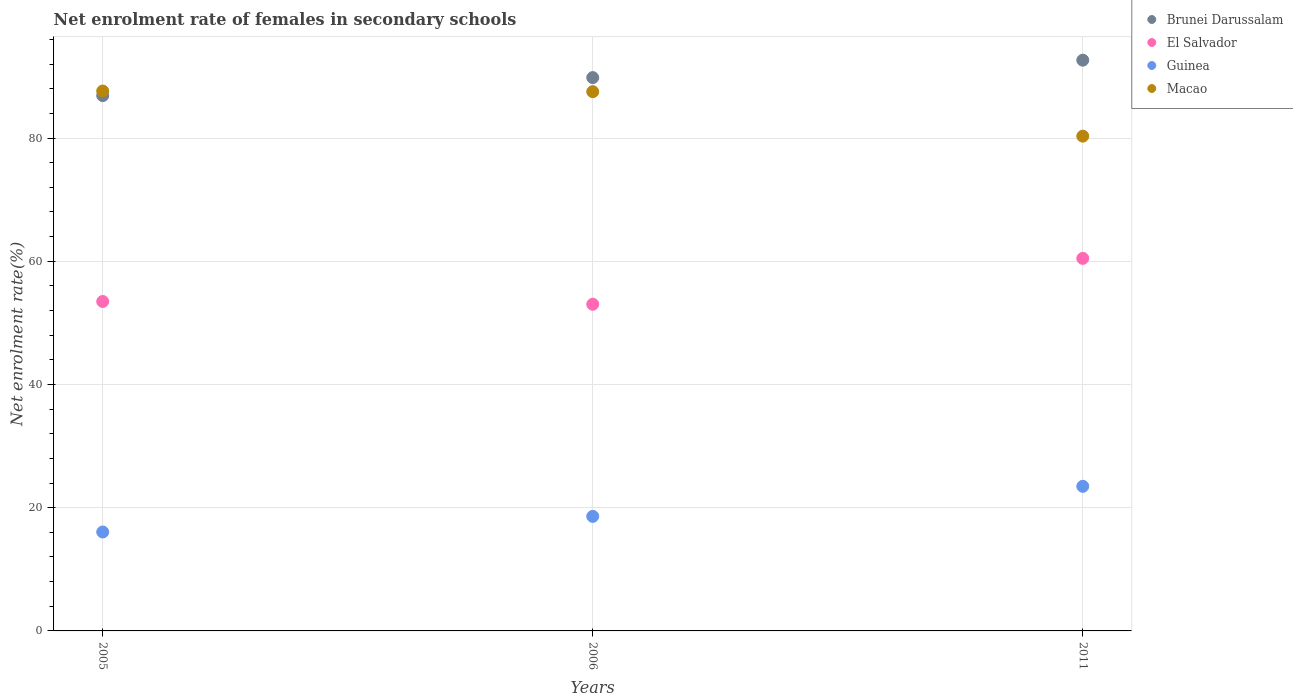How many different coloured dotlines are there?
Provide a succinct answer. 4. Is the number of dotlines equal to the number of legend labels?
Offer a terse response. Yes. What is the net enrolment rate of females in secondary schools in Brunei Darussalam in 2006?
Give a very brief answer. 89.81. Across all years, what is the maximum net enrolment rate of females in secondary schools in Guinea?
Keep it short and to the point. 23.47. Across all years, what is the minimum net enrolment rate of females in secondary schools in Macao?
Your answer should be compact. 80.31. In which year was the net enrolment rate of females in secondary schools in Macao minimum?
Provide a short and direct response. 2011. What is the total net enrolment rate of females in secondary schools in Brunei Darussalam in the graph?
Ensure brevity in your answer.  269.33. What is the difference between the net enrolment rate of females in secondary schools in El Salvador in 2005 and that in 2006?
Your answer should be compact. 0.45. What is the difference between the net enrolment rate of females in secondary schools in Guinea in 2006 and the net enrolment rate of females in secondary schools in Macao in 2011?
Offer a terse response. -61.72. What is the average net enrolment rate of females in secondary schools in Brunei Darussalam per year?
Ensure brevity in your answer.  89.78. In the year 2011, what is the difference between the net enrolment rate of females in secondary schools in Guinea and net enrolment rate of females in secondary schools in Macao?
Ensure brevity in your answer.  -56.84. What is the ratio of the net enrolment rate of females in secondary schools in Brunei Darussalam in 2005 to that in 2011?
Provide a succinct answer. 0.94. What is the difference between the highest and the second highest net enrolment rate of females in secondary schools in El Salvador?
Give a very brief answer. 7. What is the difference between the highest and the lowest net enrolment rate of females in secondary schools in Guinea?
Make the answer very short. 7.42. In how many years, is the net enrolment rate of females in secondary schools in El Salvador greater than the average net enrolment rate of females in secondary schools in El Salvador taken over all years?
Keep it short and to the point. 1. Is the net enrolment rate of females in secondary schools in Macao strictly less than the net enrolment rate of females in secondary schools in Guinea over the years?
Offer a terse response. No. How many dotlines are there?
Make the answer very short. 4. How many years are there in the graph?
Give a very brief answer. 3. Does the graph contain grids?
Give a very brief answer. Yes. Where does the legend appear in the graph?
Give a very brief answer. Top right. How many legend labels are there?
Provide a succinct answer. 4. How are the legend labels stacked?
Your response must be concise. Vertical. What is the title of the graph?
Ensure brevity in your answer.  Net enrolment rate of females in secondary schools. What is the label or title of the Y-axis?
Offer a terse response. Net enrolment rate(%). What is the Net enrolment rate(%) in Brunei Darussalam in 2005?
Offer a very short reply. 86.88. What is the Net enrolment rate(%) in El Salvador in 2005?
Provide a short and direct response. 53.47. What is the Net enrolment rate(%) in Guinea in 2005?
Give a very brief answer. 16.06. What is the Net enrolment rate(%) of Macao in 2005?
Provide a short and direct response. 87.63. What is the Net enrolment rate(%) in Brunei Darussalam in 2006?
Your answer should be very brief. 89.81. What is the Net enrolment rate(%) in El Salvador in 2006?
Your response must be concise. 53.02. What is the Net enrolment rate(%) of Guinea in 2006?
Offer a very short reply. 18.59. What is the Net enrolment rate(%) in Macao in 2006?
Provide a short and direct response. 87.53. What is the Net enrolment rate(%) in Brunei Darussalam in 2011?
Your answer should be compact. 92.64. What is the Net enrolment rate(%) in El Salvador in 2011?
Your answer should be compact. 60.47. What is the Net enrolment rate(%) in Guinea in 2011?
Make the answer very short. 23.47. What is the Net enrolment rate(%) of Macao in 2011?
Your answer should be compact. 80.31. Across all years, what is the maximum Net enrolment rate(%) in Brunei Darussalam?
Offer a terse response. 92.64. Across all years, what is the maximum Net enrolment rate(%) of El Salvador?
Your answer should be very brief. 60.47. Across all years, what is the maximum Net enrolment rate(%) in Guinea?
Your response must be concise. 23.47. Across all years, what is the maximum Net enrolment rate(%) of Macao?
Ensure brevity in your answer.  87.63. Across all years, what is the minimum Net enrolment rate(%) of Brunei Darussalam?
Keep it short and to the point. 86.88. Across all years, what is the minimum Net enrolment rate(%) of El Salvador?
Give a very brief answer. 53.02. Across all years, what is the minimum Net enrolment rate(%) of Guinea?
Ensure brevity in your answer.  16.06. Across all years, what is the minimum Net enrolment rate(%) in Macao?
Offer a terse response. 80.31. What is the total Net enrolment rate(%) of Brunei Darussalam in the graph?
Provide a short and direct response. 269.33. What is the total Net enrolment rate(%) in El Salvador in the graph?
Offer a terse response. 166.96. What is the total Net enrolment rate(%) in Guinea in the graph?
Your answer should be very brief. 58.12. What is the total Net enrolment rate(%) of Macao in the graph?
Your response must be concise. 255.46. What is the difference between the Net enrolment rate(%) in Brunei Darussalam in 2005 and that in 2006?
Offer a terse response. -2.93. What is the difference between the Net enrolment rate(%) of El Salvador in 2005 and that in 2006?
Your response must be concise. 0.45. What is the difference between the Net enrolment rate(%) of Guinea in 2005 and that in 2006?
Ensure brevity in your answer.  -2.54. What is the difference between the Net enrolment rate(%) of Macao in 2005 and that in 2006?
Your answer should be very brief. 0.1. What is the difference between the Net enrolment rate(%) of Brunei Darussalam in 2005 and that in 2011?
Your answer should be compact. -5.75. What is the difference between the Net enrolment rate(%) in El Salvador in 2005 and that in 2011?
Offer a very short reply. -7. What is the difference between the Net enrolment rate(%) of Guinea in 2005 and that in 2011?
Provide a succinct answer. -7.42. What is the difference between the Net enrolment rate(%) of Macao in 2005 and that in 2011?
Provide a succinct answer. 7.32. What is the difference between the Net enrolment rate(%) in Brunei Darussalam in 2006 and that in 2011?
Provide a succinct answer. -2.83. What is the difference between the Net enrolment rate(%) in El Salvador in 2006 and that in 2011?
Give a very brief answer. -7.45. What is the difference between the Net enrolment rate(%) in Guinea in 2006 and that in 2011?
Provide a succinct answer. -4.88. What is the difference between the Net enrolment rate(%) in Macao in 2006 and that in 2011?
Provide a short and direct response. 7.22. What is the difference between the Net enrolment rate(%) in Brunei Darussalam in 2005 and the Net enrolment rate(%) in El Salvador in 2006?
Provide a succinct answer. 33.86. What is the difference between the Net enrolment rate(%) of Brunei Darussalam in 2005 and the Net enrolment rate(%) of Guinea in 2006?
Make the answer very short. 68.29. What is the difference between the Net enrolment rate(%) in Brunei Darussalam in 2005 and the Net enrolment rate(%) in Macao in 2006?
Offer a terse response. -0.64. What is the difference between the Net enrolment rate(%) in El Salvador in 2005 and the Net enrolment rate(%) in Guinea in 2006?
Ensure brevity in your answer.  34.88. What is the difference between the Net enrolment rate(%) of El Salvador in 2005 and the Net enrolment rate(%) of Macao in 2006?
Your answer should be compact. -34.05. What is the difference between the Net enrolment rate(%) in Guinea in 2005 and the Net enrolment rate(%) in Macao in 2006?
Offer a terse response. -71.47. What is the difference between the Net enrolment rate(%) in Brunei Darussalam in 2005 and the Net enrolment rate(%) in El Salvador in 2011?
Offer a terse response. 26.42. What is the difference between the Net enrolment rate(%) in Brunei Darussalam in 2005 and the Net enrolment rate(%) in Guinea in 2011?
Your answer should be very brief. 63.41. What is the difference between the Net enrolment rate(%) of Brunei Darussalam in 2005 and the Net enrolment rate(%) of Macao in 2011?
Provide a short and direct response. 6.58. What is the difference between the Net enrolment rate(%) in El Salvador in 2005 and the Net enrolment rate(%) in Guinea in 2011?
Give a very brief answer. 30. What is the difference between the Net enrolment rate(%) in El Salvador in 2005 and the Net enrolment rate(%) in Macao in 2011?
Keep it short and to the point. -26.84. What is the difference between the Net enrolment rate(%) of Guinea in 2005 and the Net enrolment rate(%) of Macao in 2011?
Your answer should be compact. -64.25. What is the difference between the Net enrolment rate(%) in Brunei Darussalam in 2006 and the Net enrolment rate(%) in El Salvador in 2011?
Make the answer very short. 29.34. What is the difference between the Net enrolment rate(%) in Brunei Darussalam in 2006 and the Net enrolment rate(%) in Guinea in 2011?
Provide a short and direct response. 66.34. What is the difference between the Net enrolment rate(%) of Brunei Darussalam in 2006 and the Net enrolment rate(%) of Macao in 2011?
Your answer should be compact. 9.5. What is the difference between the Net enrolment rate(%) of El Salvador in 2006 and the Net enrolment rate(%) of Guinea in 2011?
Offer a very short reply. 29.55. What is the difference between the Net enrolment rate(%) in El Salvador in 2006 and the Net enrolment rate(%) in Macao in 2011?
Provide a succinct answer. -27.29. What is the difference between the Net enrolment rate(%) in Guinea in 2006 and the Net enrolment rate(%) in Macao in 2011?
Your answer should be compact. -61.72. What is the average Net enrolment rate(%) in Brunei Darussalam per year?
Make the answer very short. 89.78. What is the average Net enrolment rate(%) in El Salvador per year?
Provide a short and direct response. 55.65. What is the average Net enrolment rate(%) of Guinea per year?
Make the answer very short. 19.37. What is the average Net enrolment rate(%) of Macao per year?
Keep it short and to the point. 85.15. In the year 2005, what is the difference between the Net enrolment rate(%) in Brunei Darussalam and Net enrolment rate(%) in El Salvador?
Ensure brevity in your answer.  33.41. In the year 2005, what is the difference between the Net enrolment rate(%) of Brunei Darussalam and Net enrolment rate(%) of Guinea?
Keep it short and to the point. 70.83. In the year 2005, what is the difference between the Net enrolment rate(%) in Brunei Darussalam and Net enrolment rate(%) in Macao?
Keep it short and to the point. -0.74. In the year 2005, what is the difference between the Net enrolment rate(%) in El Salvador and Net enrolment rate(%) in Guinea?
Ensure brevity in your answer.  37.41. In the year 2005, what is the difference between the Net enrolment rate(%) of El Salvador and Net enrolment rate(%) of Macao?
Ensure brevity in your answer.  -34.16. In the year 2005, what is the difference between the Net enrolment rate(%) of Guinea and Net enrolment rate(%) of Macao?
Your answer should be compact. -71.57. In the year 2006, what is the difference between the Net enrolment rate(%) in Brunei Darussalam and Net enrolment rate(%) in El Salvador?
Your answer should be compact. 36.79. In the year 2006, what is the difference between the Net enrolment rate(%) of Brunei Darussalam and Net enrolment rate(%) of Guinea?
Offer a terse response. 71.22. In the year 2006, what is the difference between the Net enrolment rate(%) in Brunei Darussalam and Net enrolment rate(%) in Macao?
Give a very brief answer. 2.28. In the year 2006, what is the difference between the Net enrolment rate(%) of El Salvador and Net enrolment rate(%) of Guinea?
Your answer should be very brief. 34.43. In the year 2006, what is the difference between the Net enrolment rate(%) in El Salvador and Net enrolment rate(%) in Macao?
Your answer should be compact. -34.51. In the year 2006, what is the difference between the Net enrolment rate(%) in Guinea and Net enrolment rate(%) in Macao?
Give a very brief answer. -68.93. In the year 2011, what is the difference between the Net enrolment rate(%) in Brunei Darussalam and Net enrolment rate(%) in El Salvador?
Offer a very short reply. 32.17. In the year 2011, what is the difference between the Net enrolment rate(%) in Brunei Darussalam and Net enrolment rate(%) in Guinea?
Your answer should be very brief. 69.17. In the year 2011, what is the difference between the Net enrolment rate(%) in Brunei Darussalam and Net enrolment rate(%) in Macao?
Your answer should be very brief. 12.33. In the year 2011, what is the difference between the Net enrolment rate(%) in El Salvador and Net enrolment rate(%) in Guinea?
Your answer should be compact. 37. In the year 2011, what is the difference between the Net enrolment rate(%) in El Salvador and Net enrolment rate(%) in Macao?
Provide a short and direct response. -19.84. In the year 2011, what is the difference between the Net enrolment rate(%) in Guinea and Net enrolment rate(%) in Macao?
Offer a very short reply. -56.84. What is the ratio of the Net enrolment rate(%) in Brunei Darussalam in 2005 to that in 2006?
Your response must be concise. 0.97. What is the ratio of the Net enrolment rate(%) of El Salvador in 2005 to that in 2006?
Ensure brevity in your answer.  1.01. What is the ratio of the Net enrolment rate(%) in Guinea in 2005 to that in 2006?
Offer a terse response. 0.86. What is the ratio of the Net enrolment rate(%) of Brunei Darussalam in 2005 to that in 2011?
Your answer should be very brief. 0.94. What is the ratio of the Net enrolment rate(%) in El Salvador in 2005 to that in 2011?
Your response must be concise. 0.88. What is the ratio of the Net enrolment rate(%) in Guinea in 2005 to that in 2011?
Your answer should be very brief. 0.68. What is the ratio of the Net enrolment rate(%) of Macao in 2005 to that in 2011?
Your response must be concise. 1.09. What is the ratio of the Net enrolment rate(%) of Brunei Darussalam in 2006 to that in 2011?
Provide a succinct answer. 0.97. What is the ratio of the Net enrolment rate(%) in El Salvador in 2006 to that in 2011?
Ensure brevity in your answer.  0.88. What is the ratio of the Net enrolment rate(%) in Guinea in 2006 to that in 2011?
Your response must be concise. 0.79. What is the ratio of the Net enrolment rate(%) of Macao in 2006 to that in 2011?
Keep it short and to the point. 1.09. What is the difference between the highest and the second highest Net enrolment rate(%) in Brunei Darussalam?
Provide a succinct answer. 2.83. What is the difference between the highest and the second highest Net enrolment rate(%) in El Salvador?
Offer a terse response. 7. What is the difference between the highest and the second highest Net enrolment rate(%) of Guinea?
Offer a terse response. 4.88. What is the difference between the highest and the second highest Net enrolment rate(%) of Macao?
Your response must be concise. 0.1. What is the difference between the highest and the lowest Net enrolment rate(%) in Brunei Darussalam?
Give a very brief answer. 5.75. What is the difference between the highest and the lowest Net enrolment rate(%) of El Salvador?
Your answer should be compact. 7.45. What is the difference between the highest and the lowest Net enrolment rate(%) of Guinea?
Ensure brevity in your answer.  7.42. What is the difference between the highest and the lowest Net enrolment rate(%) of Macao?
Offer a terse response. 7.32. 